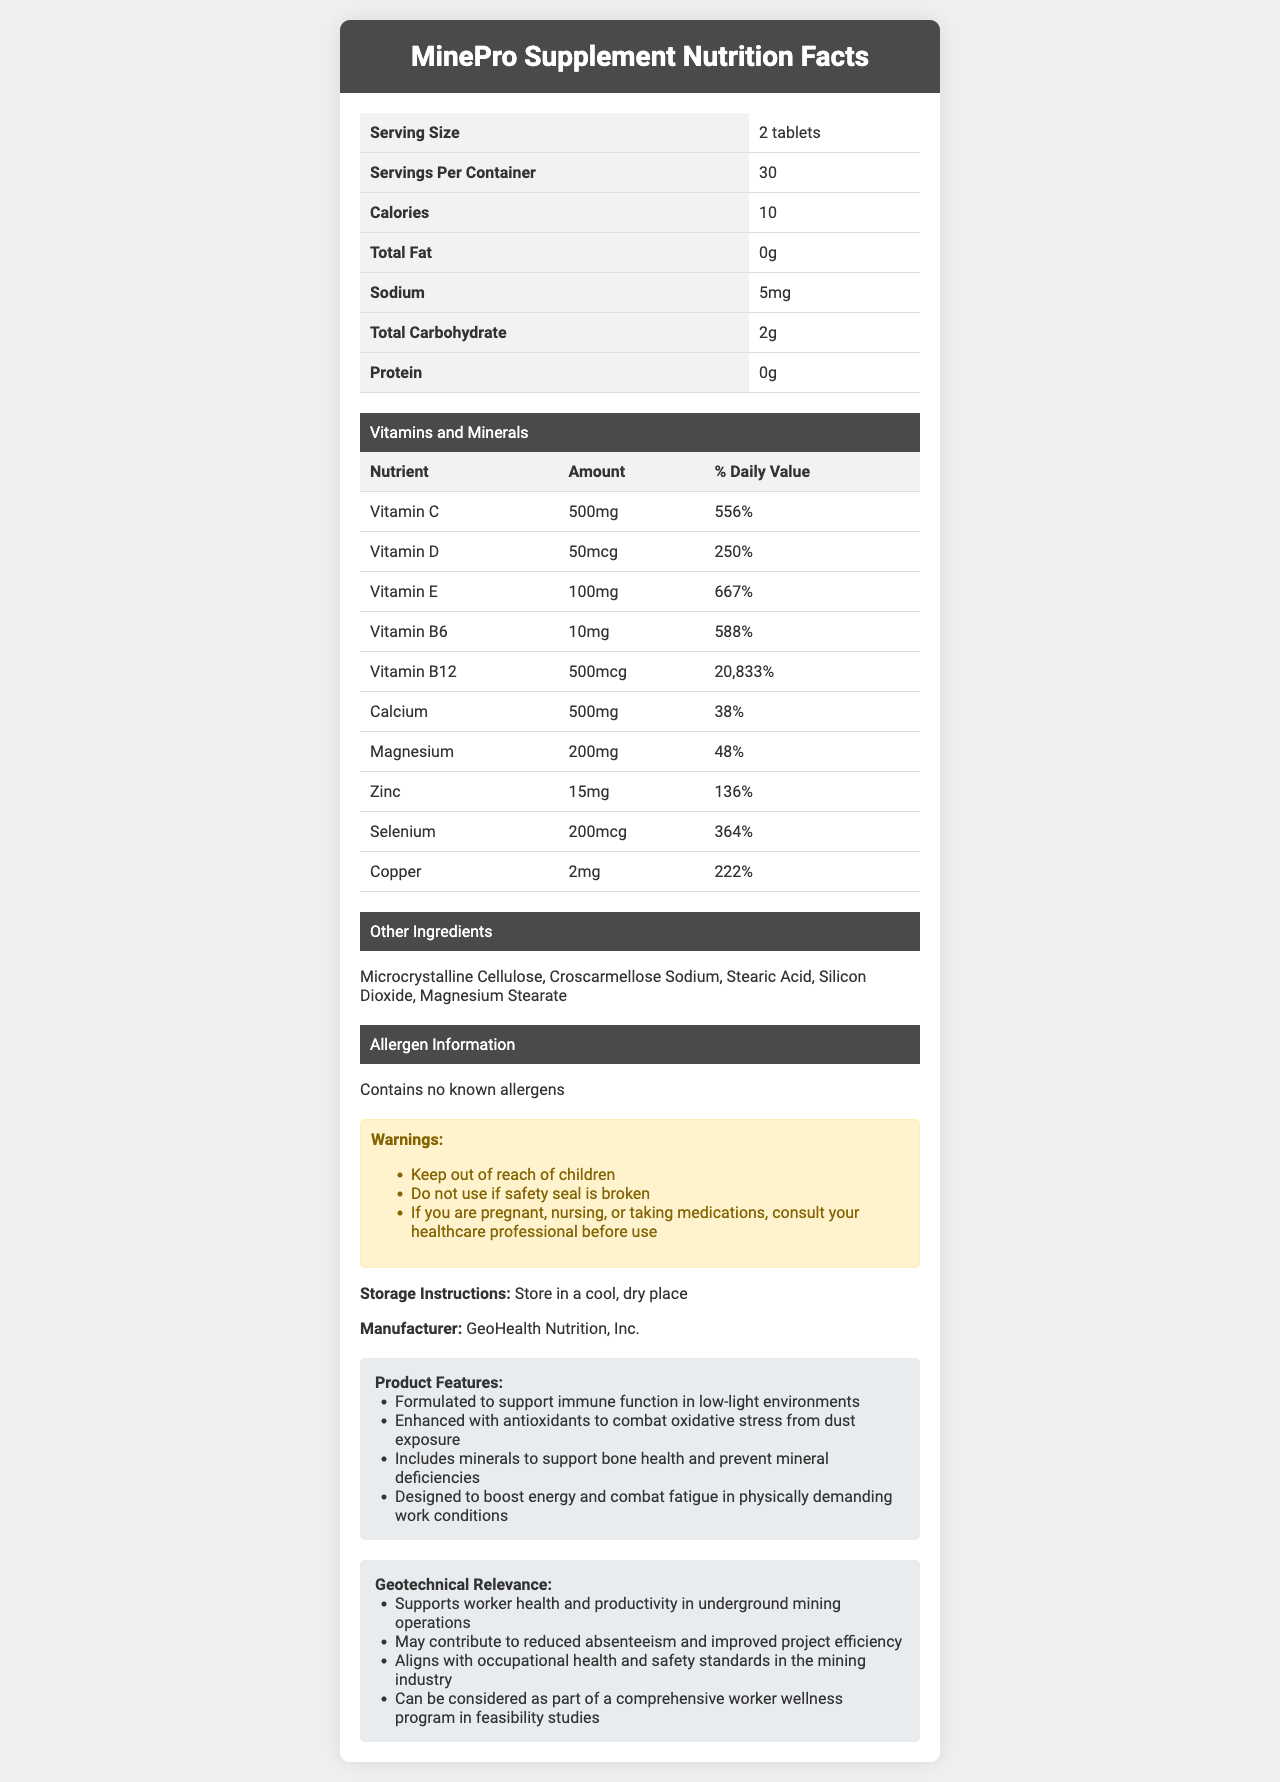what is the serving size of MinePro Supplement? The serving size is listed as "2 tablets" under the Serving Size section of the document.
Answer: 2 tablets how many servings per container are available? The document states that there are 30 servings per container.
Answer: 30 what is the amount of Vitamin C in MinePro Supplement? The document lists the amount of Vitamin C as 500mg in the Vitamins and Minerals section.
Answer: 500mg what is the daily value percentage for Vitamin E? According to the document, the daily value percentage for Vitamin E is 667%.
Answer: 667% what are the other ingredients listed in MinePro Supplement? The Other Ingredients section of the document lists these ingredients.
Answer: Microcrystalline Cellulose, Croscarmellose Sodium, Stearic Acid, Silicon Dioxide, Magnesium Stearate what is the main purpose of MinePro Supplement? A. Improve digestion B. Support immune function and combat fatigue C. Weight loss The document mentions that MinePro Supplement is formulated to support immune function and combat fatigue, among other features.
Answer: B which of the following minerals is not included in MinePro Supplement? A. Calcium B. Iron C. Zinc D. Magnesium Iron is not listed among the minerals in the Vitamins and Minerals section of the document.
Answer: B is MinePro Supplement safe for pregnant women without consultation? The document includes a warning that pregnant or nursing women should consult a healthcare professional before use.
Answer: No how does MinePro Supplement support workers in underground mining operations? The Product Features section of the document states these benefits for MinePro Supplement.
Answer: By supporting immune function, providing antioxidants, supporting bone health, and boosting energy what is the total number of warnings listed on the document? There are three warnings listed under the Warnings section.
Answer: 3 can the precise manufacturing process of MinePro Supplement be determined from the document? The document provides information about the ingredients, storage, and warnings but does not detail the manufacturing process.
Answer: Cannot be determined how should MinePro Supplement be stored? The Storage Instructions section advises storing the supplement in a cool, dry place.
Answer: In a cool, dry place who manufactures MinePro Supplement? The Manufacturer section states that GeoHealth Nutrition, Inc. manufactures MinePro Supplement.
Answer: GeoHealth Nutrition, Inc. summarize the main idea of the document. The document offers comprehensive details about MinePro Supplement, including its nutritional content, intended health benefits, and relevance to the geotechnical and mining industry.
Answer: The document provides nutrition facts, ingredients, warnings, storage instructions, manufacturer information, product features, and geotechnical relevance for MinePro Supplement, a vitamin and mineral supplement tailored for underground mining workers. 